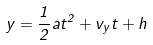Convert formula to latex. <formula><loc_0><loc_0><loc_500><loc_500>y = { \frac { 1 } { 2 } } a t ^ { 2 } + v _ { y } t + h</formula> 